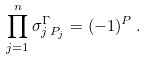<formula> <loc_0><loc_0><loc_500><loc_500>\prod _ { j = 1 } ^ { n } \sigma _ { j \, P _ { j } } ^ { \Gamma } = ( - 1 ) ^ { P } \, .</formula> 